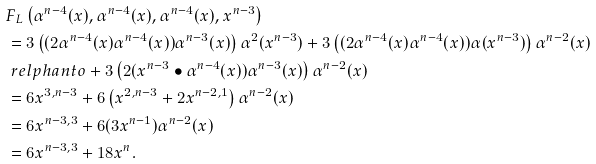<formula> <loc_0><loc_0><loc_500><loc_500>& F _ { L } \left ( \alpha ^ { n - 4 } ( x ) , \alpha ^ { n - 4 } ( x ) , \alpha ^ { n - 4 } ( x ) , x ^ { n - 3 } \right ) \\ & = 3 \left ( ( 2 \alpha ^ { n - 4 } ( x ) \alpha ^ { n - 4 } ( x ) ) \alpha ^ { n - 3 } ( x ) \right ) \alpha ^ { 2 } ( x ^ { n - 3 } ) + 3 \left ( ( 2 \alpha ^ { n - 4 } ( x ) \alpha ^ { n - 4 } ( x ) ) \alpha ( x ^ { n - 3 } ) \right ) \alpha ^ { n - 2 } ( x ) \\ & \ r e l p h a n t o + 3 \left ( 2 ( x ^ { n - 3 } \bullet \alpha ^ { n - 4 } ( x ) ) \alpha ^ { n - 3 } ( x ) \right ) \alpha ^ { n - 2 } ( x ) \\ & = 6 x ^ { 3 , n - 3 } + 6 \left ( x ^ { 2 , n - 3 } + 2 x ^ { n - 2 , 1 } \right ) \alpha ^ { n - 2 } ( x ) \\ & = 6 x ^ { n - 3 , 3 } + 6 ( 3 x ^ { n - 1 } ) \alpha ^ { n - 2 } ( x ) \\ & = 6 x ^ { n - 3 , 3 } + 1 8 x ^ { n } .</formula> 